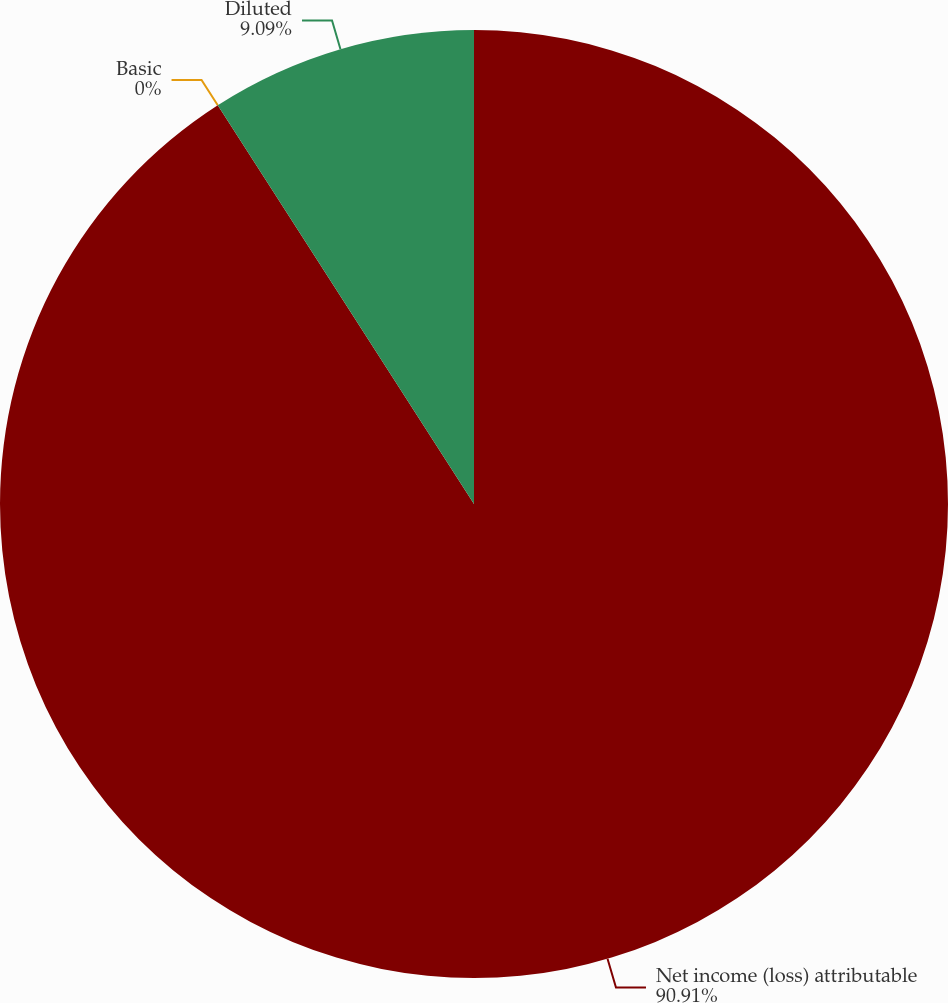<chart> <loc_0><loc_0><loc_500><loc_500><pie_chart><fcel>Net income (loss) attributable<fcel>Basic<fcel>Diluted<nl><fcel>90.91%<fcel>0.0%<fcel>9.09%<nl></chart> 